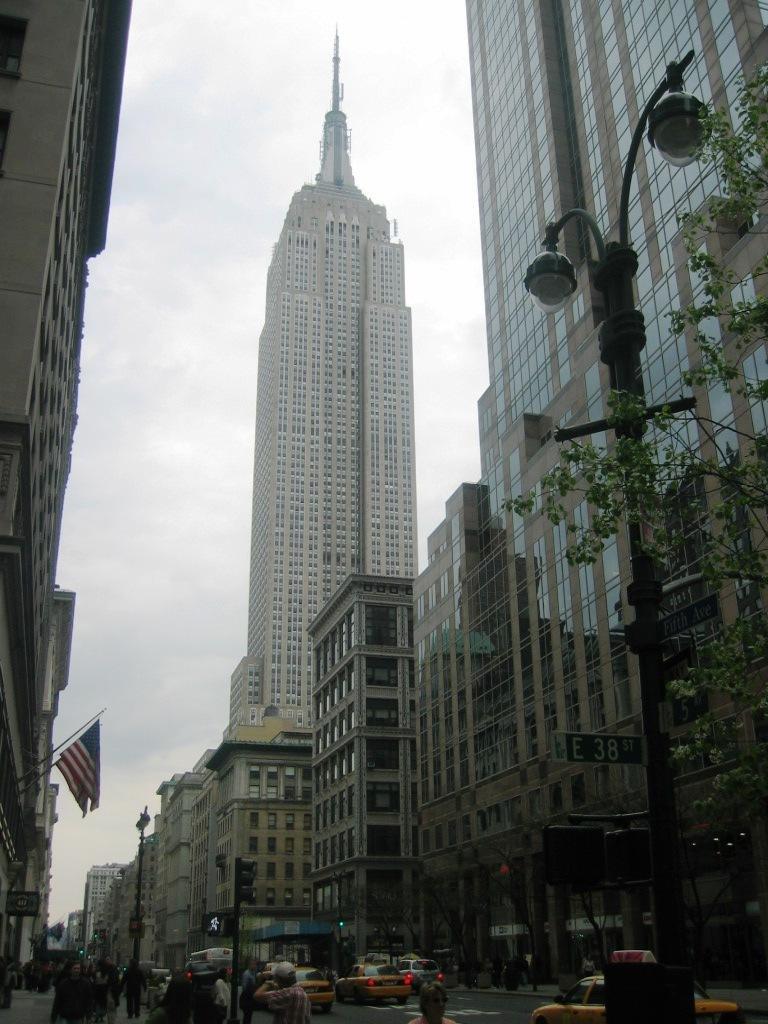In one or two sentences, can you explain what this image depicts? In this image there are many buildings and also trees. Image also consists of light poles and flags. There are few people present on the road and there are vehicles passing on the road. Sky is also visible. 